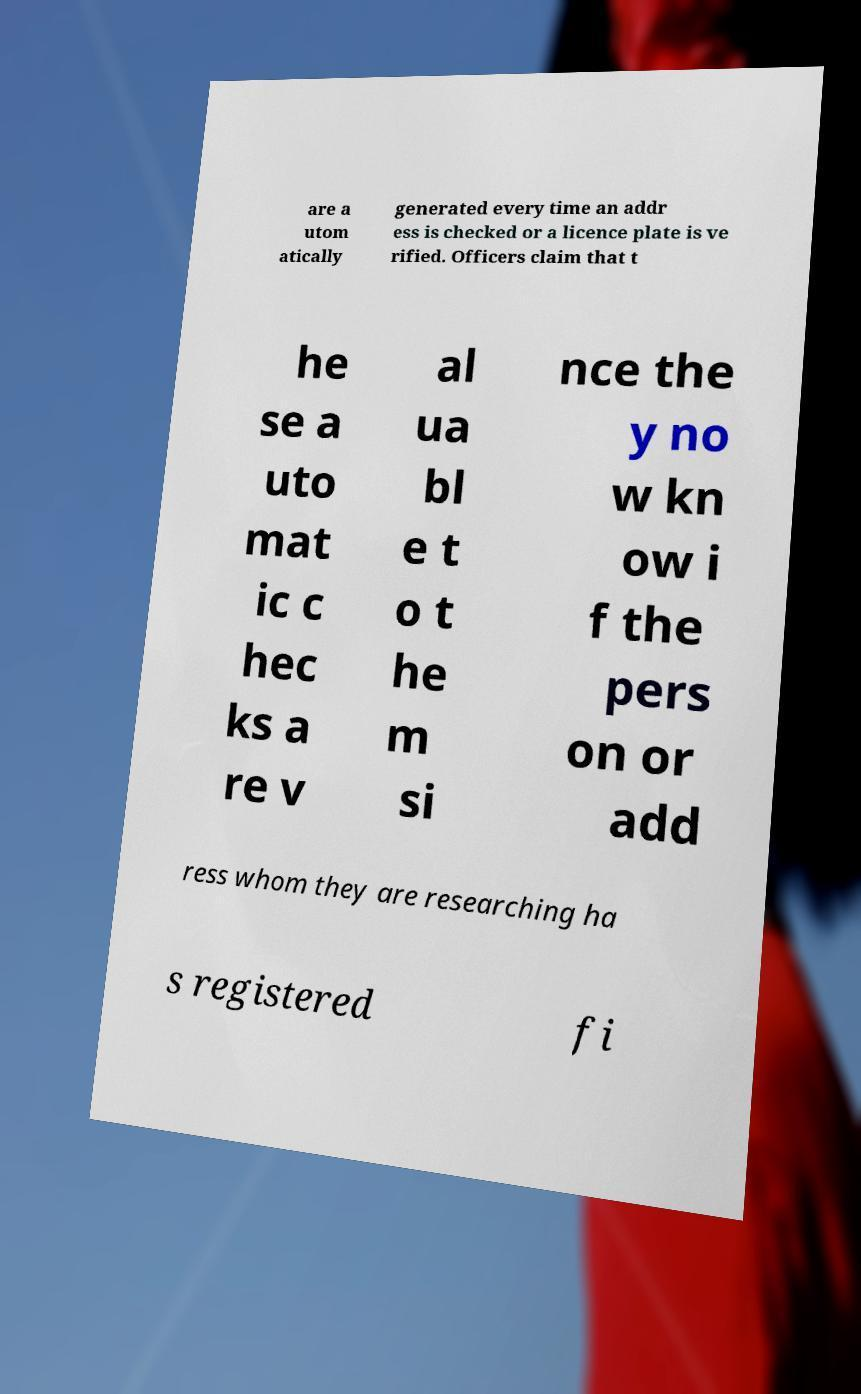There's text embedded in this image that I need extracted. Can you transcribe it verbatim? are a utom atically generated every time an addr ess is checked or a licence plate is ve rified. Officers claim that t he se a uto mat ic c hec ks a re v al ua bl e t o t he m si nce the y no w kn ow i f the pers on or add ress whom they are researching ha s registered fi 